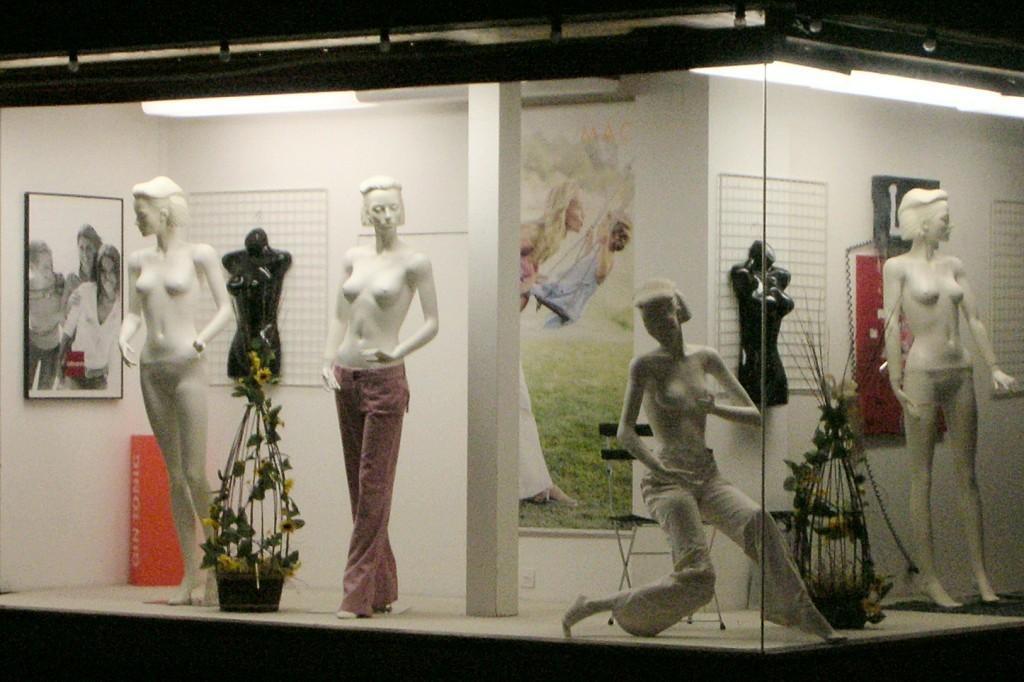Describe this image in one or two sentences. In this image I can see few mannequins standing and one mannequin is sitting on the chair. I can see two flower pot and pillar. The frames are attached to the white wall. 